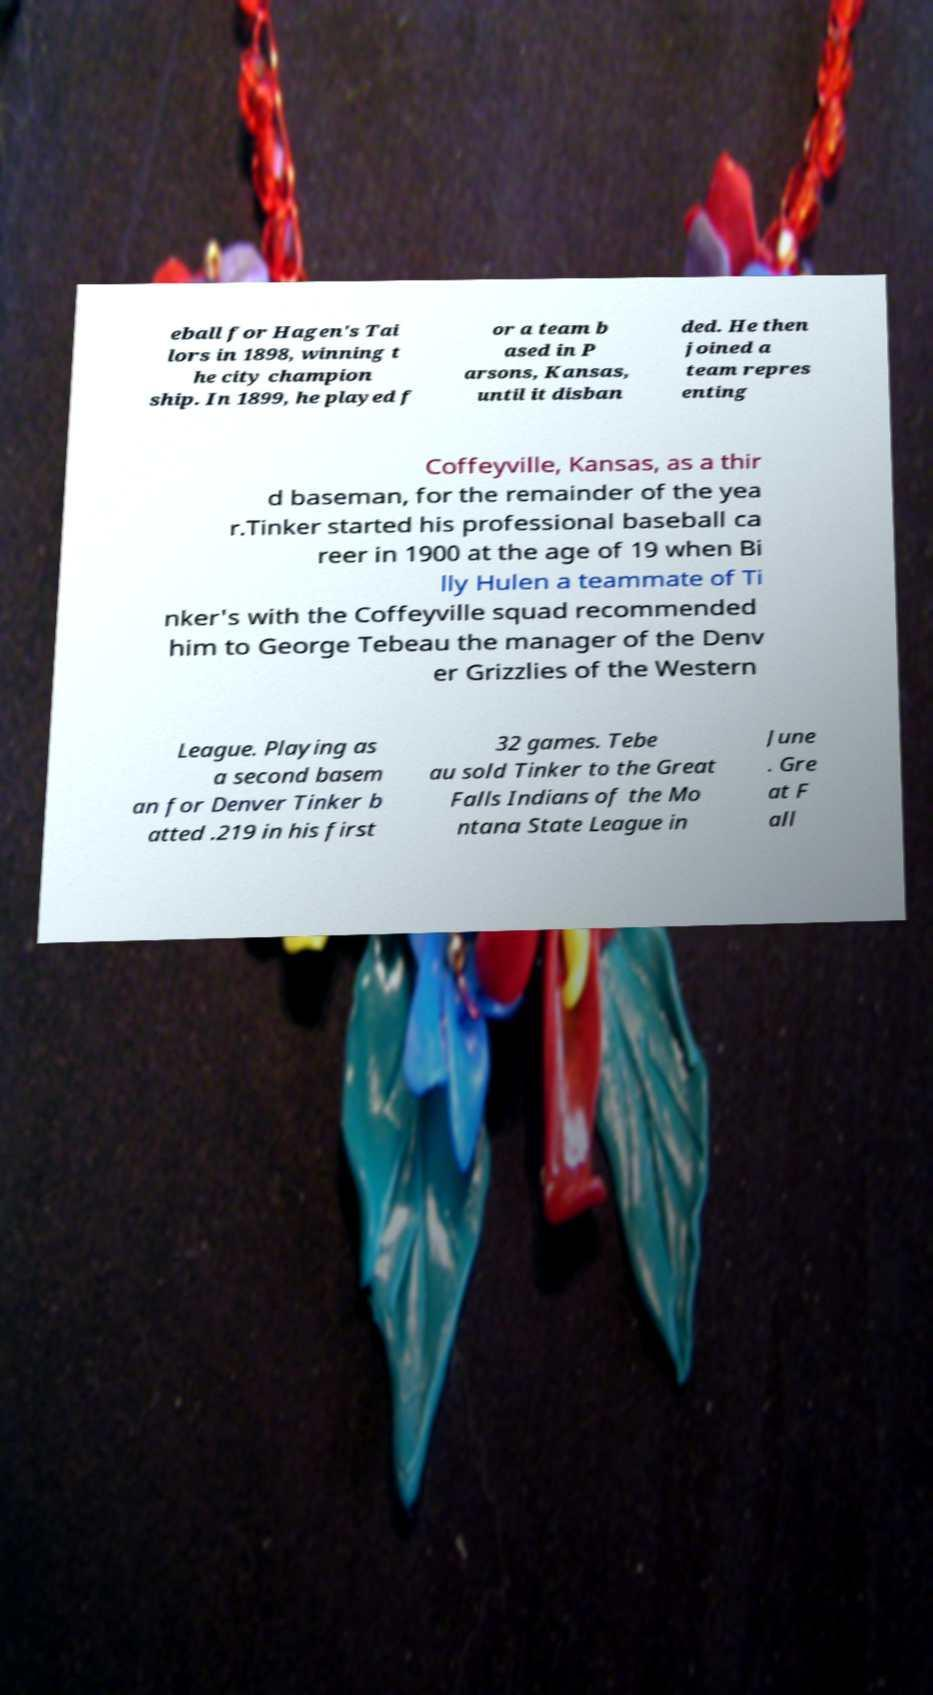Could you assist in decoding the text presented in this image and type it out clearly? eball for Hagen's Tai lors in 1898, winning t he city champion ship. In 1899, he played f or a team b ased in P arsons, Kansas, until it disban ded. He then joined a team repres enting Coffeyville, Kansas, as a thir d baseman, for the remainder of the yea r.Tinker started his professional baseball ca reer in 1900 at the age of 19 when Bi lly Hulen a teammate of Ti nker's with the Coffeyville squad recommended him to George Tebeau the manager of the Denv er Grizzlies of the Western League. Playing as a second basem an for Denver Tinker b atted .219 in his first 32 games. Tebe au sold Tinker to the Great Falls Indians of the Mo ntana State League in June . Gre at F all 